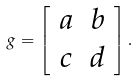Convert formula to latex. <formula><loc_0><loc_0><loc_500><loc_500>g = \left [ \begin{array} { c c } a & b \\ c & d \end{array} \right ] .</formula> 